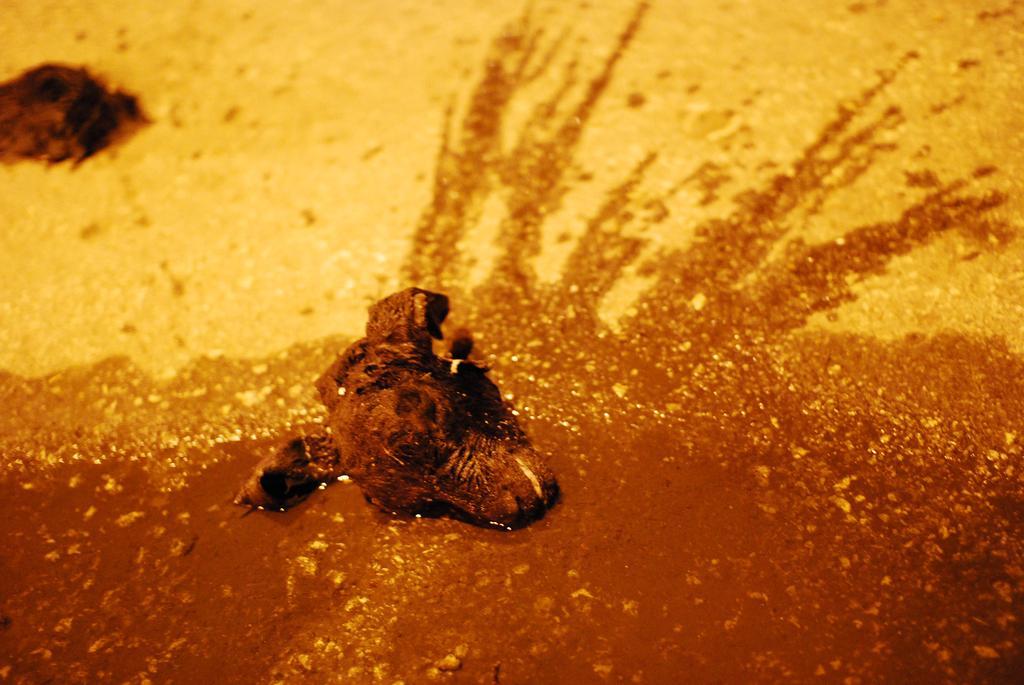Could you give a brief overview of what you see in this image? In this picture, it seems like a head of an animal in the foreground. 